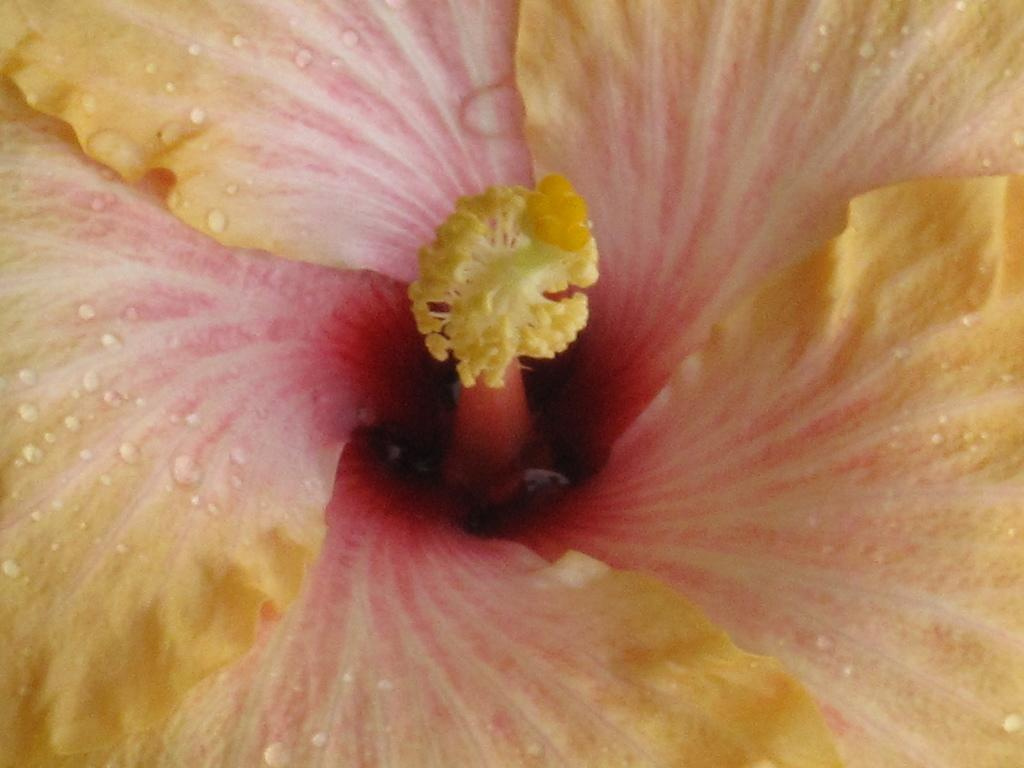What is the main subject of the image? There is a flower in the image. Where is the flower located in the image? The flower is in the front of the image. What are the main features of the flower? The flower has petals. What type of wrench is being used to adjust the flower's petals in the image? There is no wrench present in the image, and the flower's petals are not being adjusted. 